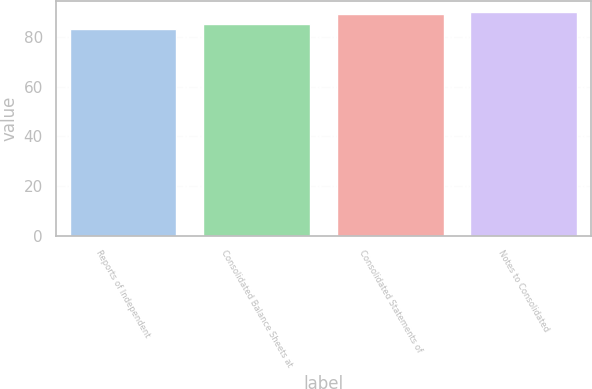Convert chart. <chart><loc_0><loc_0><loc_500><loc_500><bar_chart><fcel>Reports of Independent<fcel>Consolidated Balance Sheets at<fcel>Consolidated Statements of<fcel>Notes to Consolidated<nl><fcel>83<fcel>85<fcel>89<fcel>90<nl></chart> 